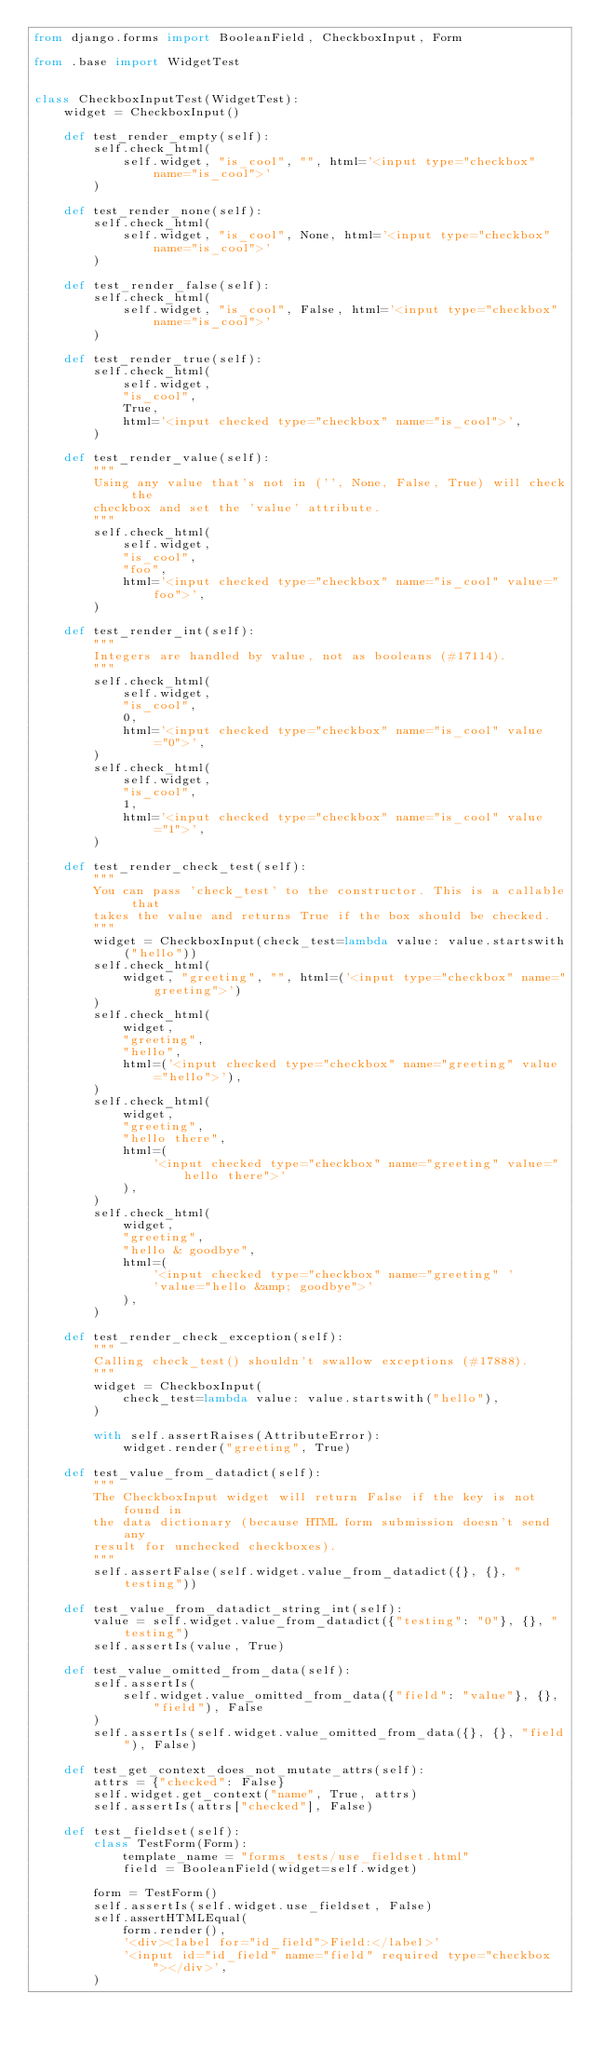Convert code to text. <code><loc_0><loc_0><loc_500><loc_500><_Python_>from django.forms import BooleanField, CheckboxInput, Form

from .base import WidgetTest


class CheckboxInputTest(WidgetTest):
    widget = CheckboxInput()

    def test_render_empty(self):
        self.check_html(
            self.widget, "is_cool", "", html='<input type="checkbox" name="is_cool">'
        )

    def test_render_none(self):
        self.check_html(
            self.widget, "is_cool", None, html='<input type="checkbox" name="is_cool">'
        )

    def test_render_false(self):
        self.check_html(
            self.widget, "is_cool", False, html='<input type="checkbox" name="is_cool">'
        )

    def test_render_true(self):
        self.check_html(
            self.widget,
            "is_cool",
            True,
            html='<input checked type="checkbox" name="is_cool">',
        )

    def test_render_value(self):
        """
        Using any value that's not in ('', None, False, True) will check the
        checkbox and set the 'value' attribute.
        """
        self.check_html(
            self.widget,
            "is_cool",
            "foo",
            html='<input checked type="checkbox" name="is_cool" value="foo">',
        )

    def test_render_int(self):
        """
        Integers are handled by value, not as booleans (#17114).
        """
        self.check_html(
            self.widget,
            "is_cool",
            0,
            html='<input checked type="checkbox" name="is_cool" value="0">',
        )
        self.check_html(
            self.widget,
            "is_cool",
            1,
            html='<input checked type="checkbox" name="is_cool" value="1">',
        )

    def test_render_check_test(self):
        """
        You can pass 'check_test' to the constructor. This is a callable that
        takes the value and returns True if the box should be checked.
        """
        widget = CheckboxInput(check_test=lambda value: value.startswith("hello"))
        self.check_html(
            widget, "greeting", "", html=('<input type="checkbox" name="greeting">')
        )
        self.check_html(
            widget,
            "greeting",
            "hello",
            html=('<input checked type="checkbox" name="greeting" value="hello">'),
        )
        self.check_html(
            widget,
            "greeting",
            "hello there",
            html=(
                '<input checked type="checkbox" name="greeting" value="hello there">'
            ),
        )
        self.check_html(
            widget,
            "greeting",
            "hello & goodbye",
            html=(
                '<input checked type="checkbox" name="greeting" '
                'value="hello &amp; goodbye">'
            ),
        )

    def test_render_check_exception(self):
        """
        Calling check_test() shouldn't swallow exceptions (#17888).
        """
        widget = CheckboxInput(
            check_test=lambda value: value.startswith("hello"),
        )

        with self.assertRaises(AttributeError):
            widget.render("greeting", True)

    def test_value_from_datadict(self):
        """
        The CheckboxInput widget will return False if the key is not found in
        the data dictionary (because HTML form submission doesn't send any
        result for unchecked checkboxes).
        """
        self.assertFalse(self.widget.value_from_datadict({}, {}, "testing"))

    def test_value_from_datadict_string_int(self):
        value = self.widget.value_from_datadict({"testing": "0"}, {}, "testing")
        self.assertIs(value, True)

    def test_value_omitted_from_data(self):
        self.assertIs(
            self.widget.value_omitted_from_data({"field": "value"}, {}, "field"), False
        )
        self.assertIs(self.widget.value_omitted_from_data({}, {}, "field"), False)

    def test_get_context_does_not_mutate_attrs(self):
        attrs = {"checked": False}
        self.widget.get_context("name", True, attrs)
        self.assertIs(attrs["checked"], False)

    def test_fieldset(self):
        class TestForm(Form):
            template_name = "forms_tests/use_fieldset.html"
            field = BooleanField(widget=self.widget)

        form = TestForm()
        self.assertIs(self.widget.use_fieldset, False)
        self.assertHTMLEqual(
            form.render(),
            '<div><label for="id_field">Field:</label>'
            '<input id="id_field" name="field" required type="checkbox"></div>',
        )
</code> 